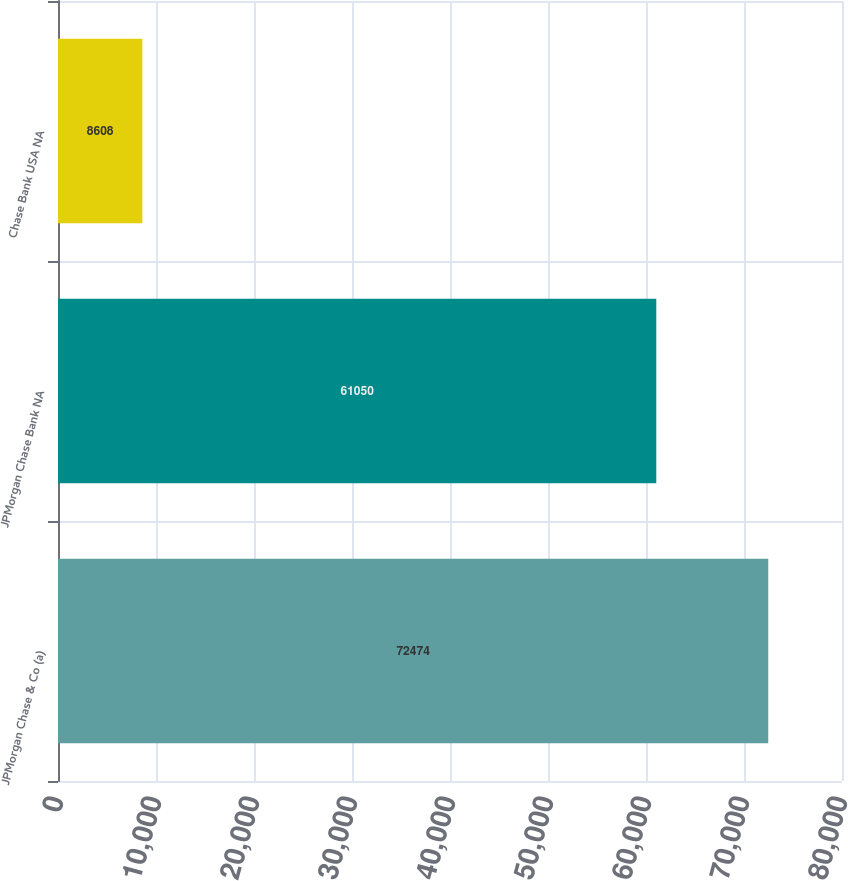Convert chart to OTSL. <chart><loc_0><loc_0><loc_500><loc_500><bar_chart><fcel>JPMorgan Chase & Co (a)<fcel>JPMorgan Chase Bank NA<fcel>Chase Bank USA NA<nl><fcel>72474<fcel>61050<fcel>8608<nl></chart> 